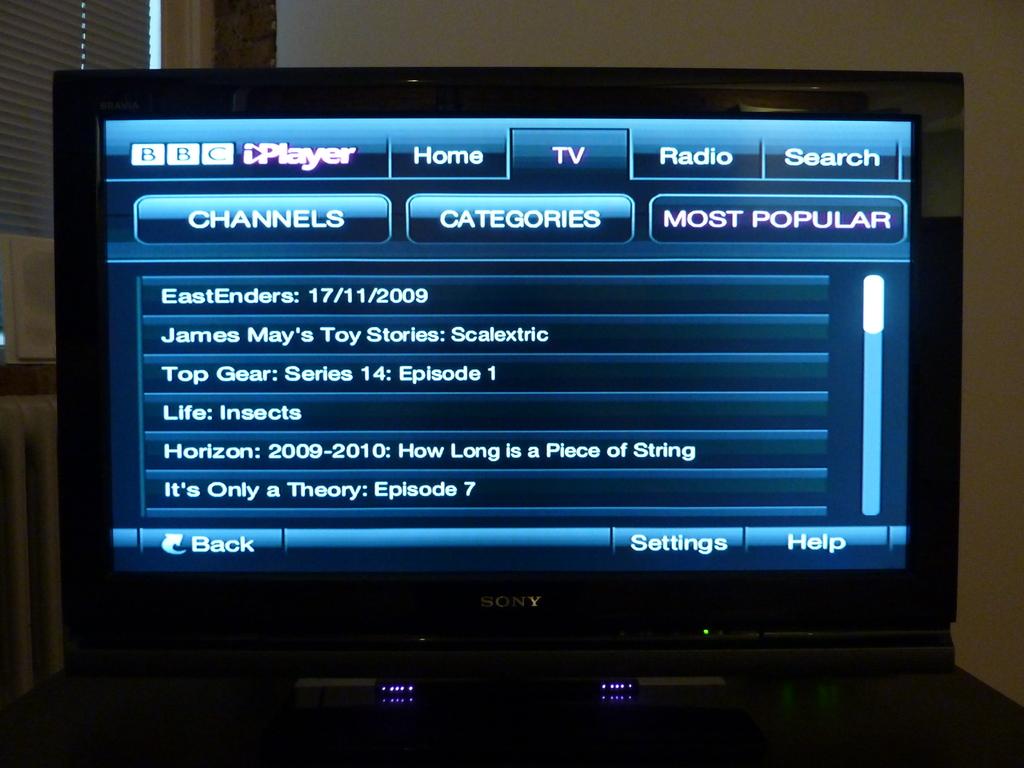What series is top gear showing?
Provide a succinct answer. 14. 